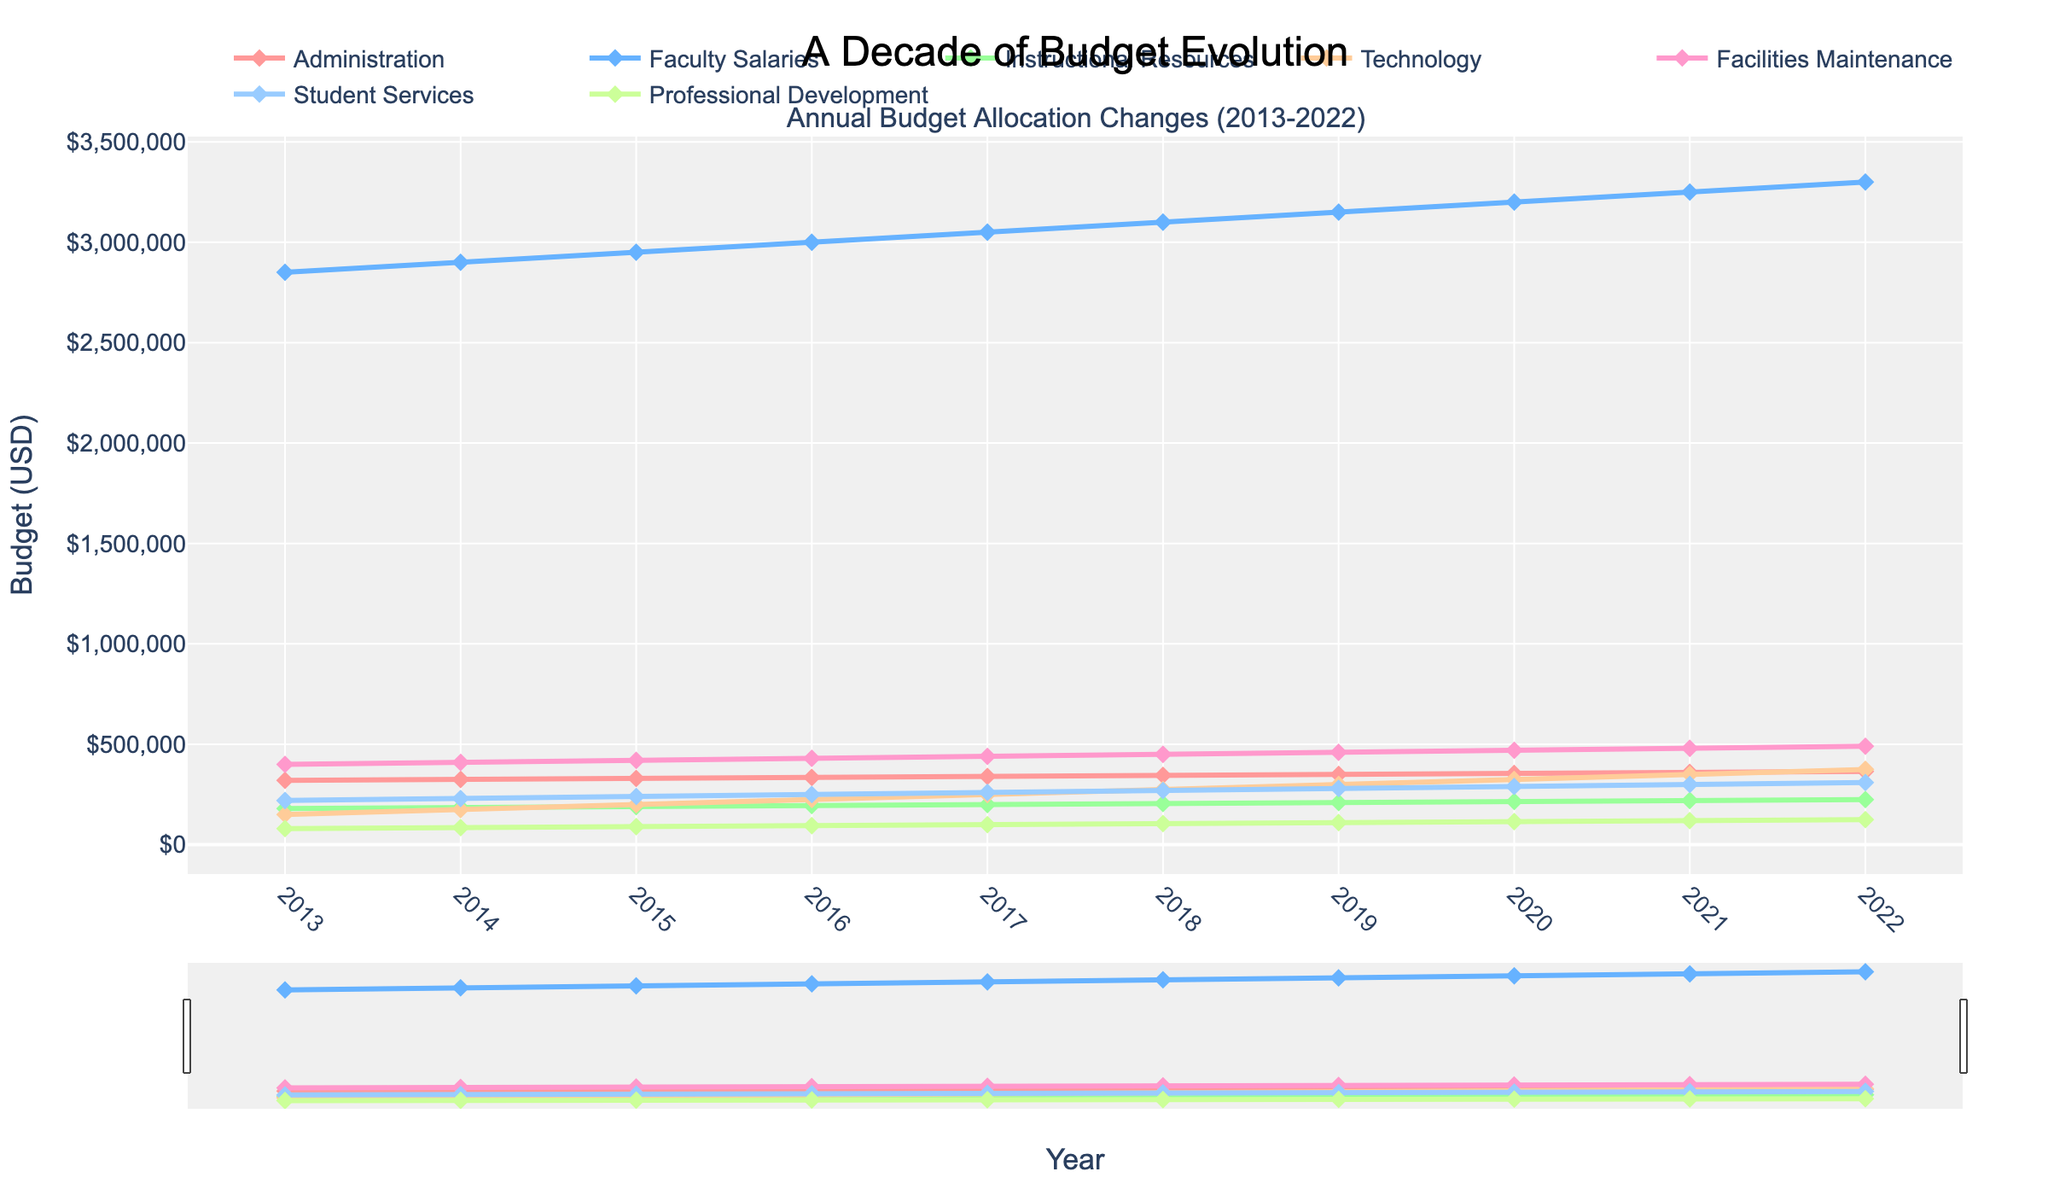What department had the highest budget allocation in 2022? First, identify the data points in 2022 for each department. The values are: Administration ($365,000), Faculty Salaries ($3,300,000), Instructional Resources ($225,000), Technology ($375,000), Facilities Maintenance ($490,000), Student Services ($310,000), and Professional Development ($125,000). Clearly, Faculty Salaries has the highest allocation.
Answer: Faculty Salaries By how much did the budget for Technology increase from 2013 to 2022? Find the budget values for Technology in 2013 ($150,000) and 2022 ($375,000). Calculate the difference: $375,000 - $150,000 = $225,000.
Answer: $225,000 Which two departments have the closest budget allocations in 2019? Check the 2019 data: Administration ($350,000), Faculty Salaries ($3,150,000), Instructional Resources ($210,000), Technology ($300,000), Facilities Maintenance ($460,000), Student Services ($280,000), and Professional Development ($110,000). The closest are Student Services ($280,000) and Instructional Resources ($210,000) with a difference of $70,000.
Answer: Student Services and Instructional Resources What is the average annual budget for Facilities Maintenance over the decade? Add the Facilities Maintenance values for each year: $400,000 + $410,000 + $420,000 + $430,000 + $440,000 + $450,000 + $460,000 + $470,000 + $480,000 + $490,000 = $4,450,000. Then divide by 10: $4,450,000 / 10 = $445,000.
Answer: $445,000 In which year did the Administration budget first exceed $330,000? Review the values: 2013 ($320,000), 2014 ($325,000), 2015 ($330,000), 2016 ($335,000). The first year it exceeded $330,000 is 2016.
Answer: 2016 What has been the yearly growth rate of the Student Services budget from 2013 to 2022? Find the difference between the budgets in 2022 ($310,000) and 2013 ($220,000): $310,000 - $220,000 = $90,000. Since the period is 9 years, the annual growth rate is $90,000 / 9 ≈ $10,000/year.
Answer: $10,000/year Which department showed the most consistent growth trend over the years? Examine the trend lines for all departments. Faculty Salaries and Facilities Maintenance show very consistent increases annually. Faculty Salaries has the most substantial and steady growth over the whole period.
Answer: Faculty Salaries 